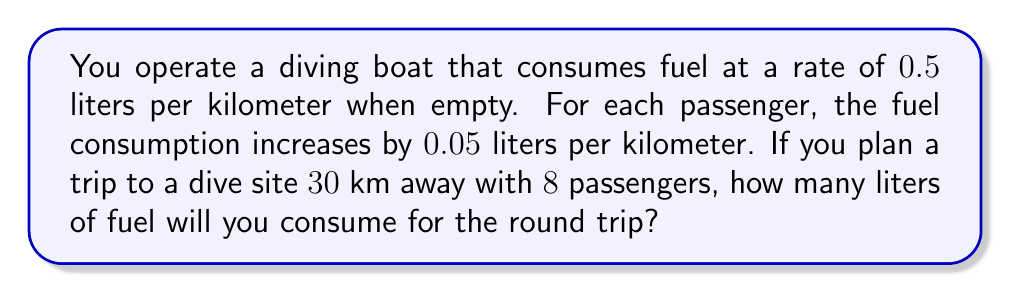What is the answer to this math problem? Let's approach this step-by-step:

1) First, let's establish the fuel consumption rate for the boat with passengers:
   Base rate: $0.5$ L/km
   Additional rate per passenger: $0.05$ L/km
   Number of passengers: $8$
   
   Total rate = $0.5 + (0.05 \times 8) = 0.5 + 0.4 = 0.9$ L/km

2) Now, let's calculate the total distance:
   Distance to dive site: $30$ km
   Round trip distance: $30 \times 2 = 60$ km

3) Finally, let's calculate the total fuel consumption:
   Fuel consumption = Rate $\times$ Distance
   $$\text{Fuel consumption} = 0.9 \text{ L/km} \times 60 \text{ km} = 54 \text{ L}$$

Therefore, you will consume $54$ liters of fuel for the round trip.
Answer: 54 liters 